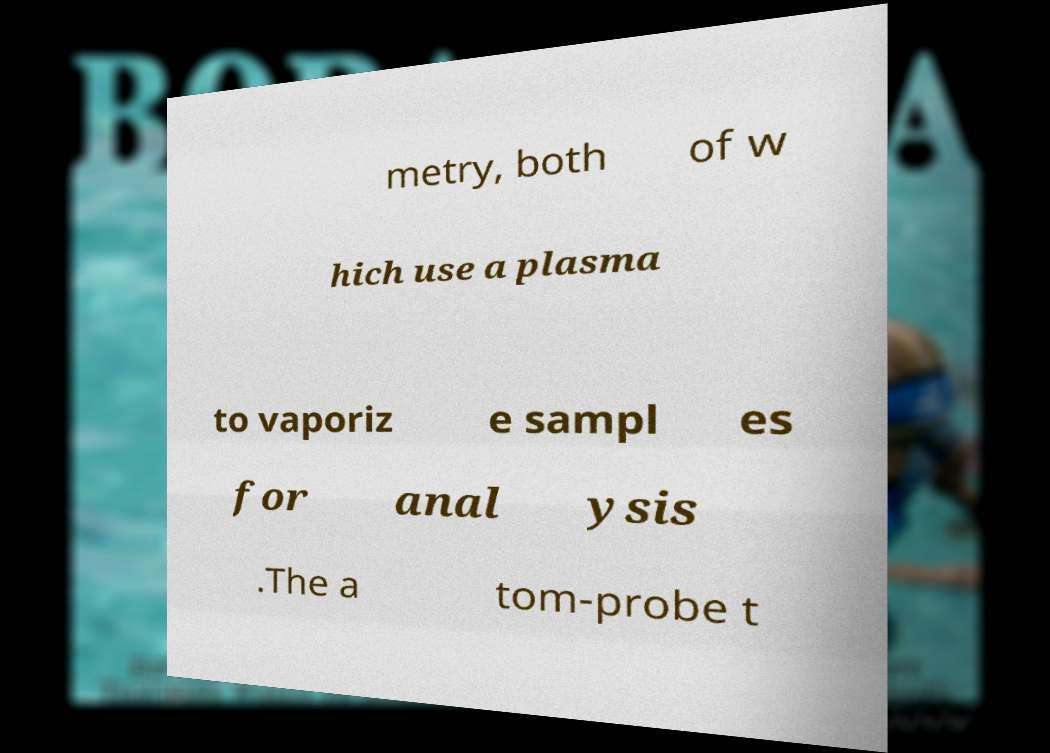Could you assist in decoding the text presented in this image and type it out clearly? metry, both of w hich use a plasma to vaporiz e sampl es for anal ysis .The a tom-probe t 